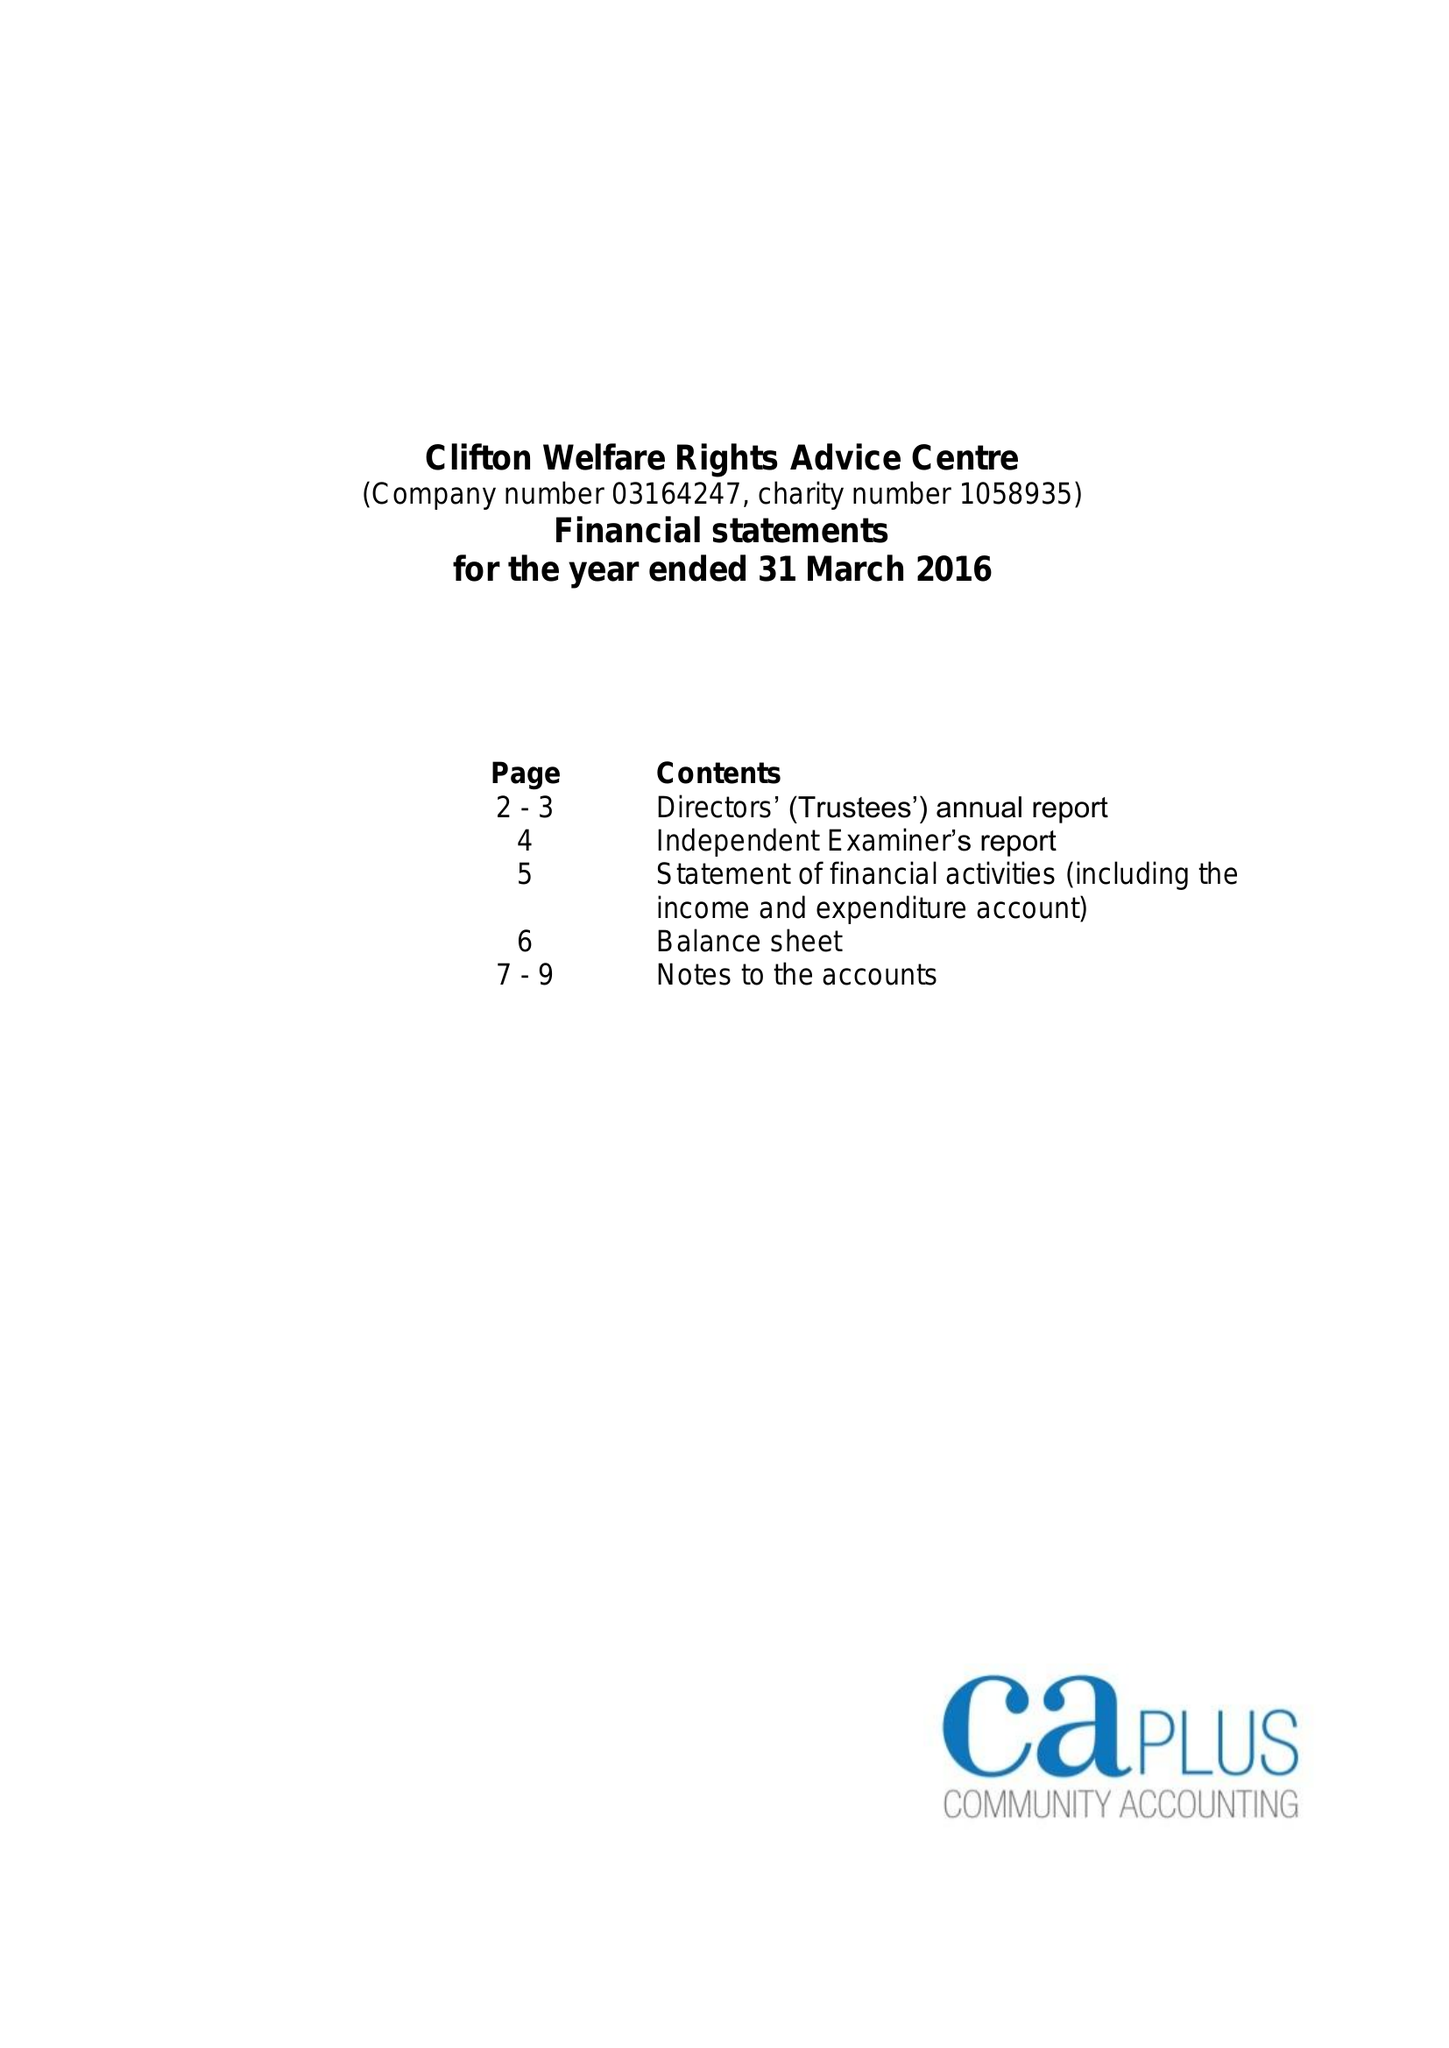What is the value for the address__postcode?
Answer the question using a single word or phrase. NG11 8EW 